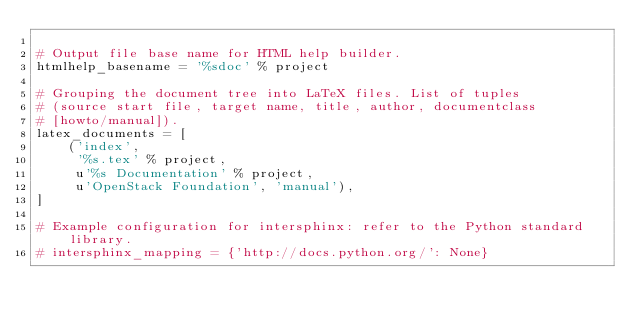<code> <loc_0><loc_0><loc_500><loc_500><_Python_>
# Output file base name for HTML help builder.
htmlhelp_basename = '%sdoc' % project

# Grouping the document tree into LaTeX files. List of tuples
# (source start file, target name, title, author, documentclass
# [howto/manual]).
latex_documents = [
    ('index',
     '%s.tex' % project,
     u'%s Documentation' % project,
     u'OpenStack Foundation', 'manual'),
]

# Example configuration for intersphinx: refer to the Python standard library.
# intersphinx_mapping = {'http://docs.python.org/': None}
</code> 